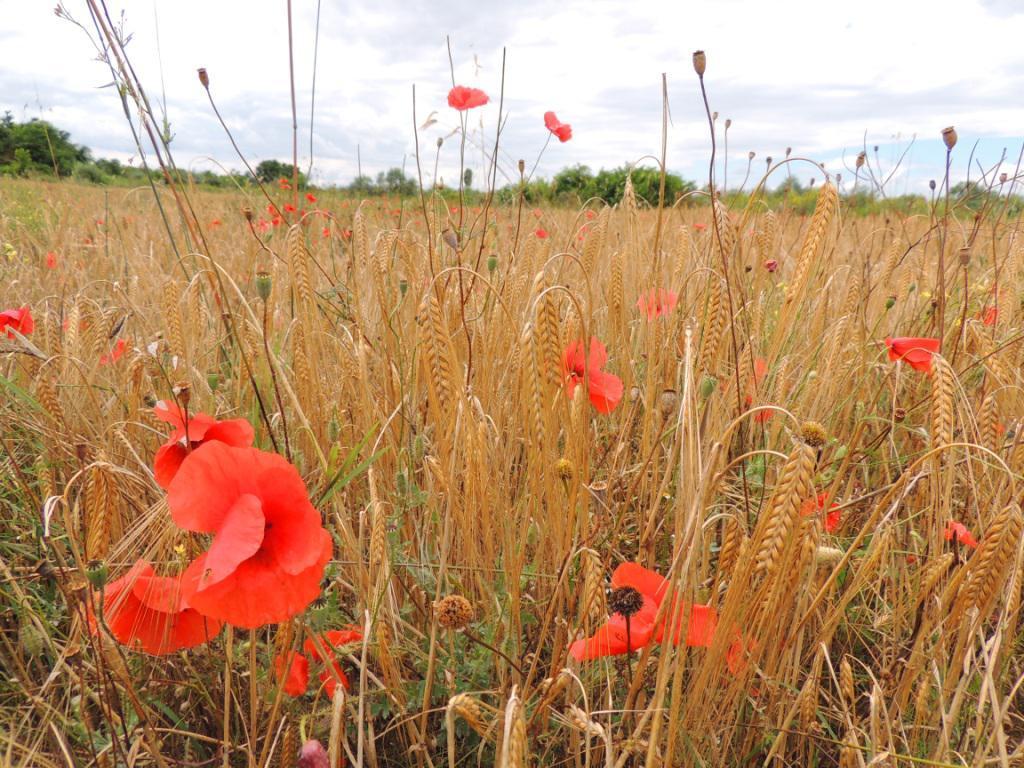In one or two sentences, can you explain what this image depicts? In this image there are few plants having flowers and buds. Behind there are few trees. Top of image there is sky. 